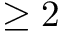<formula> <loc_0><loc_0><loc_500><loc_500>\geq 2</formula> 